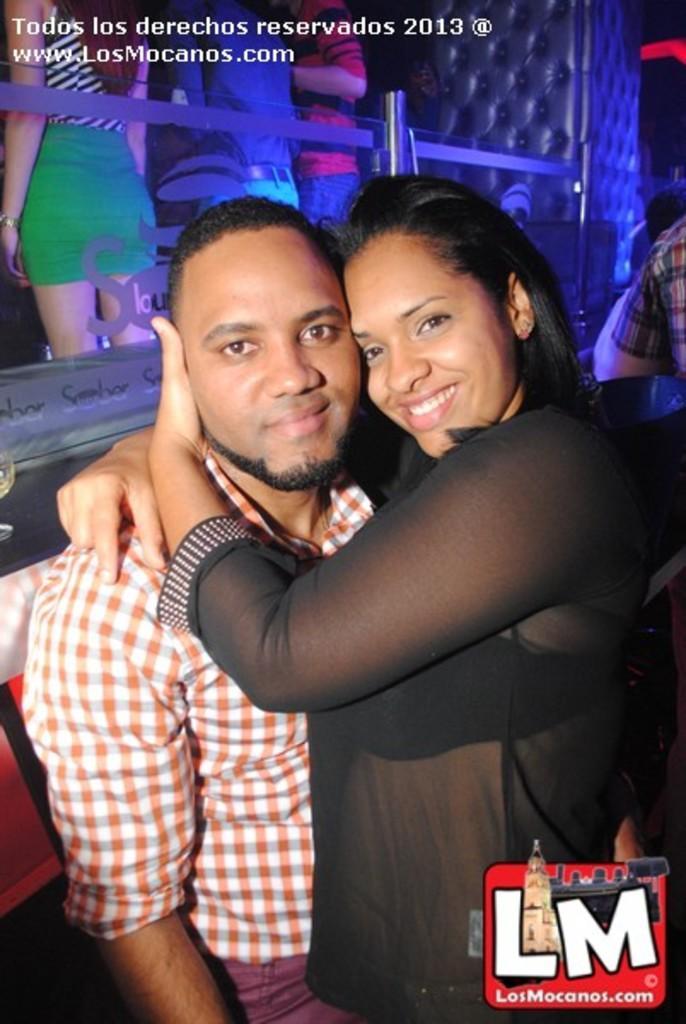Please provide a concise description of this image. There are two persons standing and holding each other and smiling. Background we can see people. Top of the image we can see text and bottom right side of the image we can see logo. 